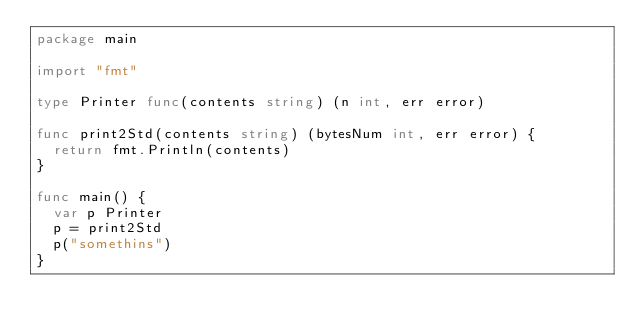Convert code to text. <code><loc_0><loc_0><loc_500><loc_500><_Go_>package main

import "fmt"

type Printer func(contents string) (n int, err error)

func print2Std(contents string) (bytesNum int, err error) {
	return fmt.Println(contents)
}

func main() {
	var p Printer
	p = print2Std
	p("somethins")
}
</code> 